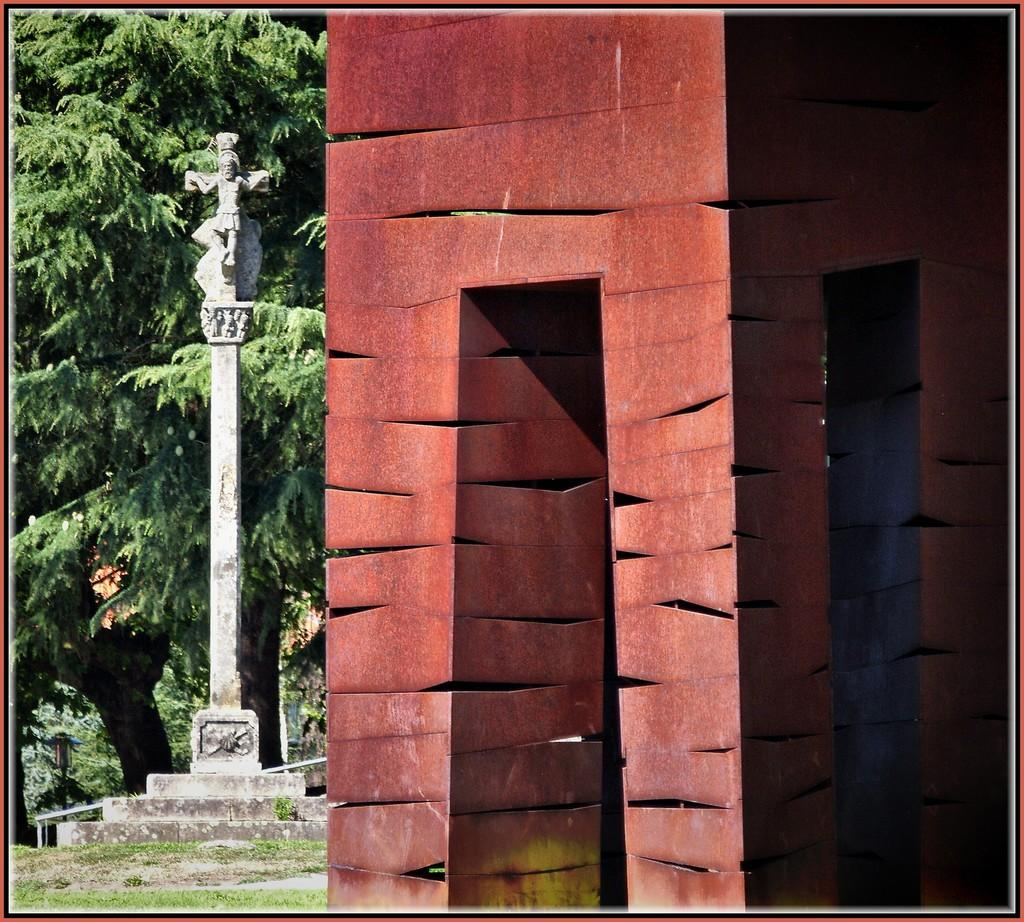What structure is located on the right side of the image? There is a building on the right side of the image. What can be seen on the left side of the image? There is a monument in the left side of the image. What type of natural elements are visible in the background of the image? There are trees in the background of the image. Where is the board located in the image? There is no board present in the image. What type of sand can be seen in the image? There is no sand present in the image. 